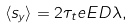<formula> <loc_0><loc_0><loc_500><loc_500>\langle s _ { y } \rangle = 2 \tau _ { t } e E D \lambda ,</formula> 